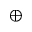Convert formula to latex. <formula><loc_0><loc_0><loc_500><loc_500>\oplus</formula> 